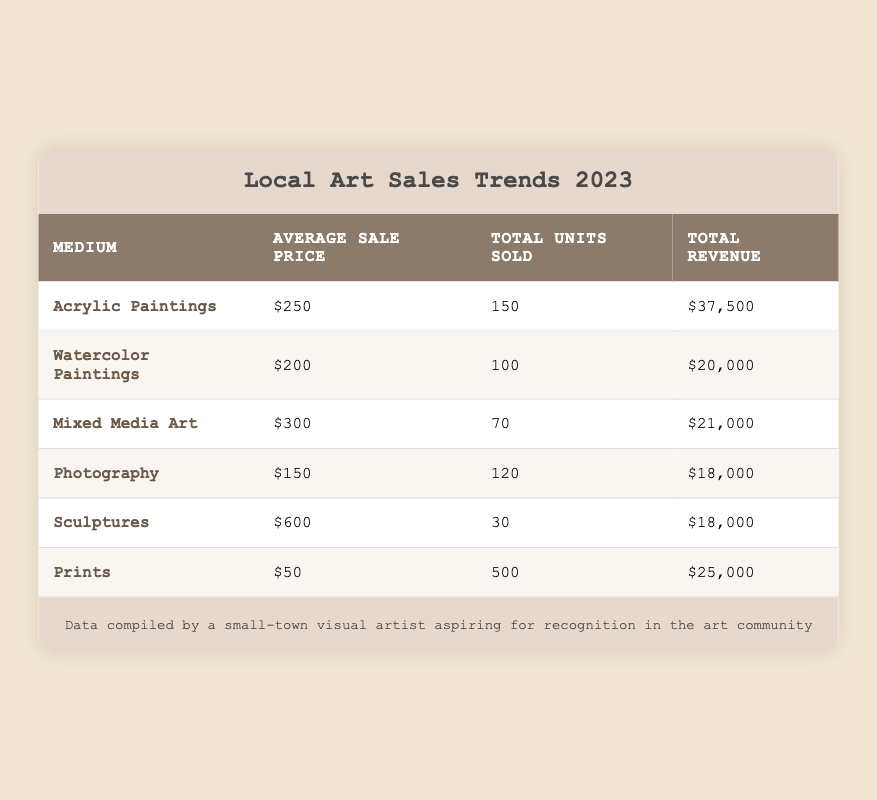What is the average sale price of Acrylic Paintings? The table states that the average sale price for Acrylic Paintings is listed directly in the corresponding cell.
Answer: 250 How many total units of Prints were sold? The number of total units sold for Prints is available in the table and can be found in the corresponding cell.
Answer: 500 Which medium had the highest average sale price? By comparing the average sale price column for each medium, it is clear that Sculptures have the highest average sale price of 600.
Answer: Sculptures Is the total revenue from Watercolor Paintings greater than that from Photography? The total revenue from Watercolor Paintings is 20000 and from Photography is 18000. 20000 is greater than 18000, so the statement is true.
Answer: Yes What is the total revenue generated by Mixed Media Art and Photography combined? The total revenue for Mixed Media Art is 21000 and for Photography it is 18000. Adding these two revenue figures gives 21000 + 18000 = 39000.
Answer: 39000 How many total units were sold for all mediums combined? To find the total units sold for all mediums, add the total units sold for each medium: 150 (Acrylic) + 100 (Watercolor) + 70 (Mixed Media) + 120 (Photography) + 30 (Sculptures) + 500 (Prints) = 1070.
Answer: 1070 Are there more units of Sculptures sold than Mixed Media Art? The total units of Sculptures sold is 30, while the total units of Mixed Media Art sold is 70. Since 30 is not greater than 70, the statement is false.
Answer: No What is the average sale price of all the mediums combined? The average sale price can be calculated by taking the sum of all average sale prices and dividing by the number of mediums: (250 + 200 + 300 + 150 + 600 + 50) / 6 = 225.
Answer: 225 Which medium generated the least total revenue? Upon reviewing the total revenue for each medium, the revenue for Photography and Sculptures is the same at 18000. Since they are tied, either can be considered as having the least revenue.
Answer: Photography or Sculptures 